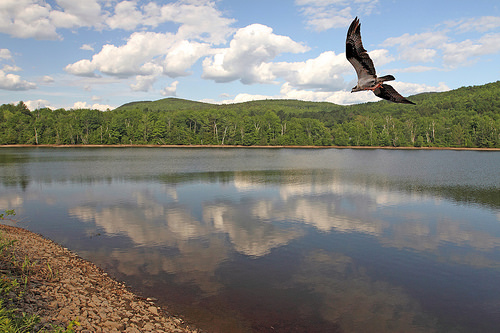<image>
Can you confirm if the bird is next to the trees? No. The bird is not positioned next to the trees. They are located in different areas of the scene. Where is the bird in relation to the water? Is it above the water? Yes. The bird is positioned above the water in the vertical space, higher up in the scene. 